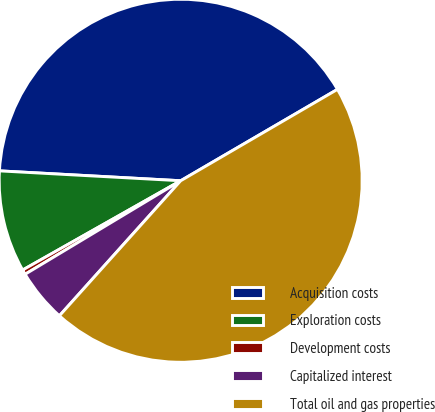Convert chart. <chart><loc_0><loc_0><loc_500><loc_500><pie_chart><fcel>Acquisition costs<fcel>Exploration costs<fcel>Development costs<fcel>Capitalized interest<fcel>Total oil and gas properties<nl><fcel>40.73%<fcel>9.05%<fcel>0.43%<fcel>4.74%<fcel>45.04%<nl></chart> 